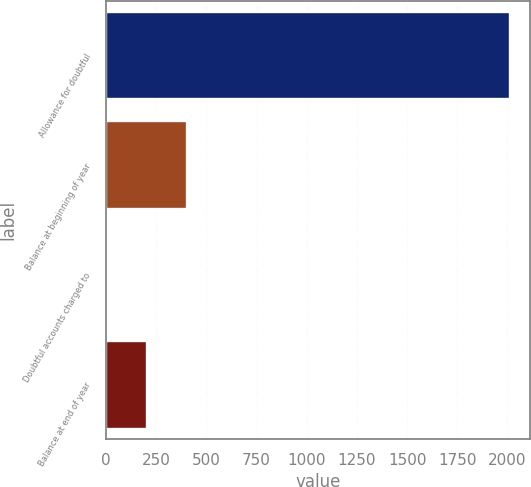Convert chart. <chart><loc_0><loc_0><loc_500><loc_500><bar_chart><fcel>Allowance for doubtful<fcel>Balance at beginning of year<fcel>Doubtful accounts charged to<fcel>Balance at end of year<nl><fcel>2012<fcel>404.8<fcel>3<fcel>203.9<nl></chart> 